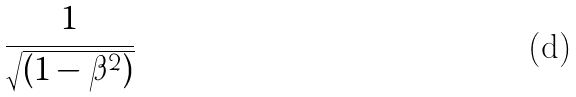<formula> <loc_0><loc_0><loc_500><loc_500>\frac { 1 } { \sqrt { ( 1 - \beta ^ { 2 } ) } }</formula> 